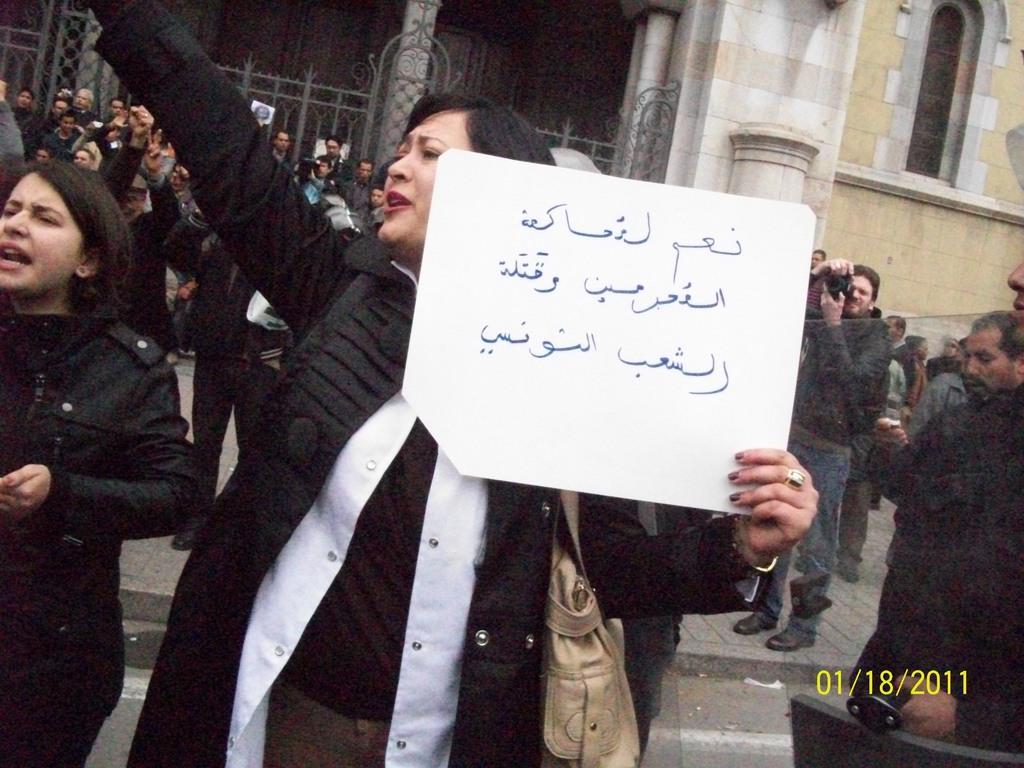Could you give a brief overview of what you see in this image? In the image we can see there are people standing on the road and there is a woman holding banner in her hand. There are other people standing at the back and there is a man holding camera in his hand. Behind there is a building. 